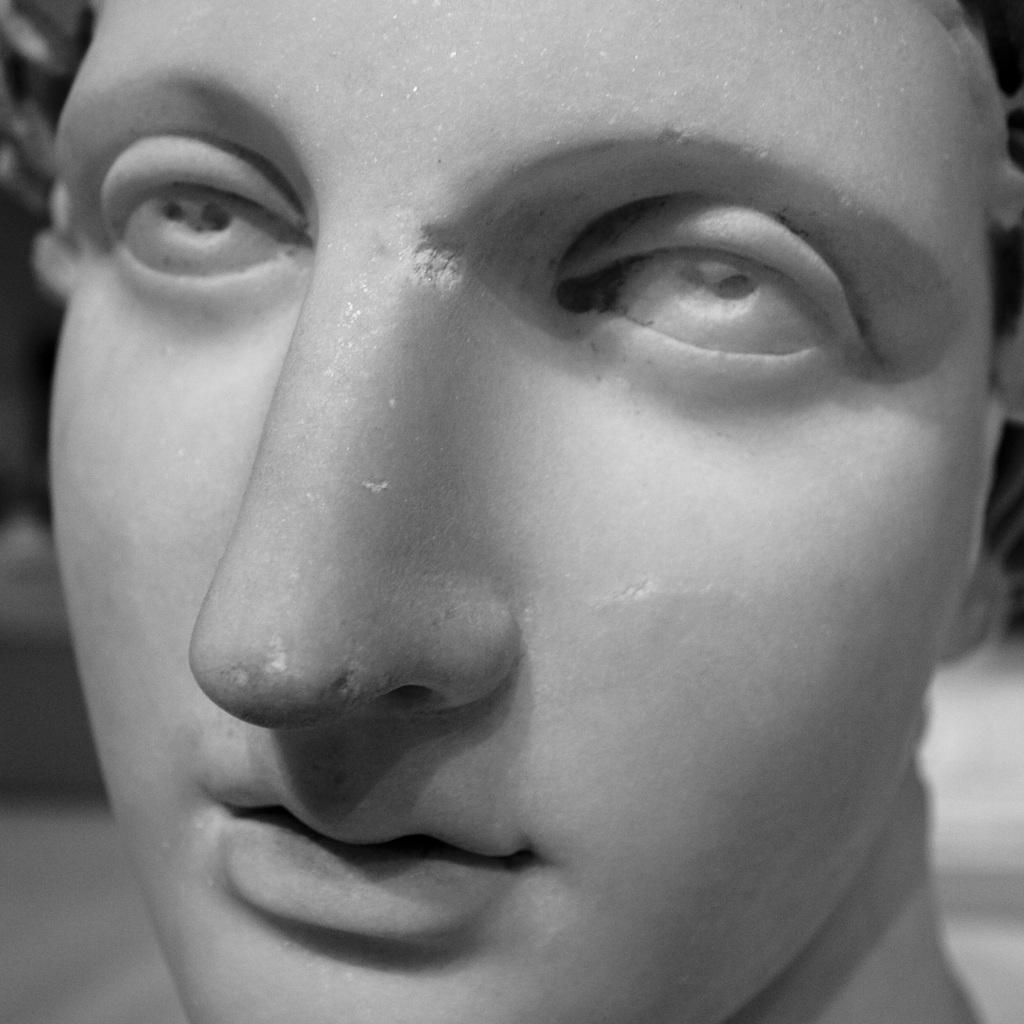What is the main subject of the image? There is a statue in the image. Can you describe the statue in more detail? The statue is of a person's face. What type of pump is being used to fuel the argument between the two people in the image? There are no people or arguments present in the image; it only features a statue of a person's face. 